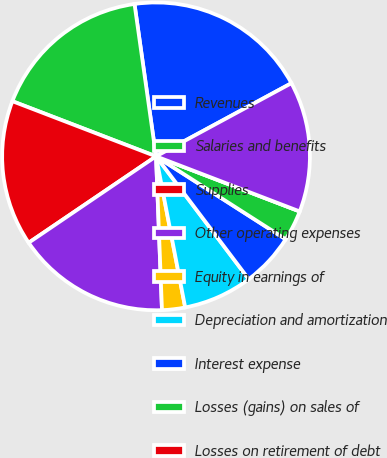Convert chart to OTSL. <chart><loc_0><loc_0><loc_500><loc_500><pie_chart><fcel>Revenues<fcel>Salaries and benefits<fcel>Supplies<fcel>Other operating expenses<fcel>Equity in earnings of<fcel>Depreciation and amortization<fcel>Interest expense<fcel>Losses (gains) on sales of<fcel>Losses on retirement of debt<fcel>Income before income taxes<nl><fcel>19.35%<fcel>16.93%<fcel>15.32%<fcel>16.13%<fcel>2.42%<fcel>7.26%<fcel>5.65%<fcel>3.23%<fcel>0.0%<fcel>13.71%<nl></chart> 